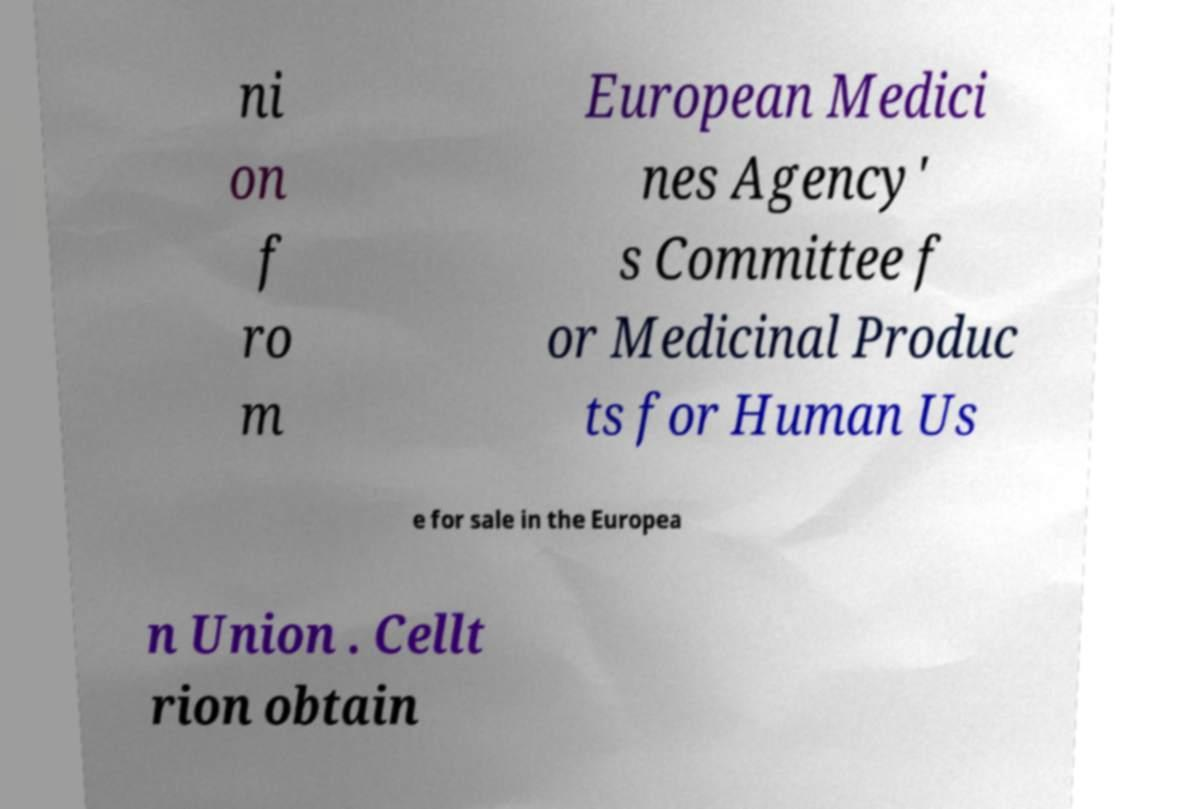Please read and relay the text visible in this image. What does it say? ni on f ro m European Medici nes Agency' s Committee f or Medicinal Produc ts for Human Us e for sale in the Europea n Union . Cellt rion obtain 